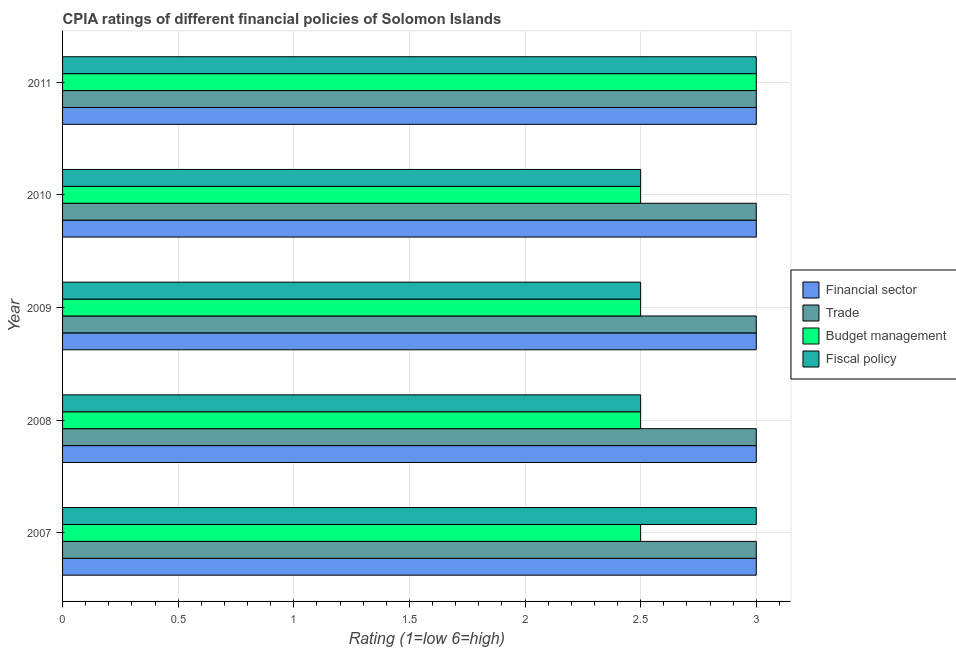How many different coloured bars are there?
Offer a very short reply. 4. Are the number of bars on each tick of the Y-axis equal?
Make the answer very short. Yes. How many bars are there on the 1st tick from the top?
Your answer should be compact. 4. What is the cpia rating of trade in 2007?
Give a very brief answer. 3. Across all years, what is the maximum cpia rating of trade?
Offer a very short reply. 3. Across all years, what is the minimum cpia rating of financial sector?
Make the answer very short. 3. In which year was the cpia rating of trade minimum?
Your response must be concise. 2007. What is the total cpia rating of fiscal policy in the graph?
Give a very brief answer. 13.5. In the year 2009, what is the difference between the cpia rating of fiscal policy and cpia rating of financial sector?
Provide a short and direct response. -0.5. Is the cpia rating of budget management in 2008 less than that in 2011?
Provide a succinct answer. Yes. Is the difference between the cpia rating of fiscal policy in 2009 and 2011 greater than the difference between the cpia rating of financial sector in 2009 and 2011?
Provide a short and direct response. No. In how many years, is the cpia rating of financial sector greater than the average cpia rating of financial sector taken over all years?
Ensure brevity in your answer.  0. Is the sum of the cpia rating of financial sector in 2007 and 2009 greater than the maximum cpia rating of fiscal policy across all years?
Your answer should be very brief. Yes. What does the 2nd bar from the top in 2008 represents?
Ensure brevity in your answer.  Budget management. What does the 3rd bar from the bottom in 2007 represents?
Ensure brevity in your answer.  Budget management. Are all the bars in the graph horizontal?
Provide a succinct answer. Yes. Does the graph contain any zero values?
Provide a succinct answer. No. Does the graph contain grids?
Keep it short and to the point. Yes. Where does the legend appear in the graph?
Your response must be concise. Center right. What is the title of the graph?
Offer a very short reply. CPIA ratings of different financial policies of Solomon Islands. Does "Trade" appear as one of the legend labels in the graph?
Make the answer very short. Yes. What is the label or title of the X-axis?
Your response must be concise. Rating (1=low 6=high). What is the label or title of the Y-axis?
Offer a terse response. Year. What is the Rating (1=low 6=high) of Trade in 2007?
Your answer should be compact. 3. What is the Rating (1=low 6=high) in Trade in 2008?
Your answer should be compact. 3. What is the Rating (1=low 6=high) in Fiscal policy in 2008?
Make the answer very short. 2.5. What is the Rating (1=low 6=high) of Budget management in 2009?
Provide a short and direct response. 2.5. What is the Rating (1=low 6=high) in Fiscal policy in 2009?
Offer a very short reply. 2.5. What is the Rating (1=low 6=high) of Fiscal policy in 2010?
Ensure brevity in your answer.  2.5. What is the Rating (1=low 6=high) in Financial sector in 2011?
Ensure brevity in your answer.  3. What is the Rating (1=low 6=high) in Budget management in 2011?
Offer a very short reply. 3. What is the Rating (1=low 6=high) of Fiscal policy in 2011?
Offer a terse response. 3. Across all years, what is the maximum Rating (1=low 6=high) of Financial sector?
Offer a terse response. 3. Across all years, what is the maximum Rating (1=low 6=high) of Fiscal policy?
Your response must be concise. 3. Across all years, what is the minimum Rating (1=low 6=high) of Budget management?
Provide a short and direct response. 2.5. Across all years, what is the minimum Rating (1=low 6=high) of Fiscal policy?
Provide a succinct answer. 2.5. What is the total Rating (1=low 6=high) of Fiscal policy in the graph?
Your response must be concise. 13.5. What is the difference between the Rating (1=low 6=high) of Financial sector in 2007 and that in 2008?
Provide a succinct answer. 0. What is the difference between the Rating (1=low 6=high) of Trade in 2007 and that in 2008?
Your answer should be compact. 0. What is the difference between the Rating (1=low 6=high) in Budget management in 2007 and that in 2008?
Offer a terse response. 0. What is the difference between the Rating (1=low 6=high) of Budget management in 2007 and that in 2009?
Ensure brevity in your answer.  0. What is the difference between the Rating (1=low 6=high) of Fiscal policy in 2007 and that in 2009?
Make the answer very short. 0.5. What is the difference between the Rating (1=low 6=high) in Financial sector in 2007 and that in 2010?
Ensure brevity in your answer.  0. What is the difference between the Rating (1=low 6=high) in Trade in 2007 and that in 2010?
Give a very brief answer. 0. What is the difference between the Rating (1=low 6=high) in Budget management in 2007 and that in 2010?
Your response must be concise. 0. What is the difference between the Rating (1=low 6=high) in Fiscal policy in 2007 and that in 2010?
Ensure brevity in your answer.  0.5. What is the difference between the Rating (1=low 6=high) in Budget management in 2007 and that in 2011?
Give a very brief answer. -0.5. What is the difference between the Rating (1=low 6=high) of Budget management in 2008 and that in 2009?
Make the answer very short. 0. What is the difference between the Rating (1=low 6=high) in Trade in 2008 and that in 2010?
Make the answer very short. 0. What is the difference between the Rating (1=low 6=high) of Budget management in 2008 and that in 2010?
Ensure brevity in your answer.  0. What is the difference between the Rating (1=low 6=high) in Financial sector in 2008 and that in 2011?
Provide a short and direct response. 0. What is the difference between the Rating (1=low 6=high) of Trade in 2008 and that in 2011?
Offer a very short reply. 0. What is the difference between the Rating (1=low 6=high) of Budget management in 2008 and that in 2011?
Your answer should be compact. -0.5. What is the difference between the Rating (1=low 6=high) of Fiscal policy in 2008 and that in 2011?
Your answer should be compact. -0.5. What is the difference between the Rating (1=low 6=high) of Financial sector in 2009 and that in 2010?
Offer a terse response. 0. What is the difference between the Rating (1=low 6=high) of Trade in 2009 and that in 2010?
Make the answer very short. 0. What is the difference between the Rating (1=low 6=high) of Budget management in 2009 and that in 2010?
Provide a short and direct response. 0. What is the difference between the Rating (1=low 6=high) of Financial sector in 2009 and that in 2011?
Provide a short and direct response. 0. What is the difference between the Rating (1=low 6=high) of Budget management in 2009 and that in 2011?
Provide a succinct answer. -0.5. What is the difference between the Rating (1=low 6=high) in Fiscal policy in 2009 and that in 2011?
Offer a terse response. -0.5. What is the difference between the Rating (1=low 6=high) in Trade in 2010 and that in 2011?
Your answer should be compact. 0. What is the difference between the Rating (1=low 6=high) of Budget management in 2010 and that in 2011?
Offer a very short reply. -0.5. What is the difference between the Rating (1=low 6=high) in Financial sector in 2007 and the Rating (1=low 6=high) in Budget management in 2008?
Offer a terse response. 0.5. What is the difference between the Rating (1=low 6=high) of Trade in 2007 and the Rating (1=low 6=high) of Budget management in 2008?
Give a very brief answer. 0.5. What is the difference between the Rating (1=low 6=high) of Budget management in 2007 and the Rating (1=low 6=high) of Fiscal policy in 2008?
Offer a very short reply. 0. What is the difference between the Rating (1=low 6=high) of Financial sector in 2007 and the Rating (1=low 6=high) of Budget management in 2009?
Ensure brevity in your answer.  0.5. What is the difference between the Rating (1=low 6=high) in Financial sector in 2007 and the Rating (1=low 6=high) in Fiscal policy in 2009?
Offer a terse response. 0.5. What is the difference between the Rating (1=low 6=high) in Trade in 2007 and the Rating (1=low 6=high) in Budget management in 2009?
Your response must be concise. 0.5. What is the difference between the Rating (1=low 6=high) in Trade in 2007 and the Rating (1=low 6=high) in Fiscal policy in 2009?
Give a very brief answer. 0.5. What is the difference between the Rating (1=low 6=high) in Budget management in 2007 and the Rating (1=low 6=high) in Fiscal policy in 2009?
Offer a very short reply. 0. What is the difference between the Rating (1=low 6=high) in Financial sector in 2007 and the Rating (1=low 6=high) in Budget management in 2010?
Offer a very short reply. 0.5. What is the difference between the Rating (1=low 6=high) of Financial sector in 2007 and the Rating (1=low 6=high) of Fiscal policy in 2010?
Offer a terse response. 0.5. What is the difference between the Rating (1=low 6=high) in Trade in 2007 and the Rating (1=low 6=high) in Budget management in 2010?
Make the answer very short. 0.5. What is the difference between the Rating (1=low 6=high) in Financial sector in 2007 and the Rating (1=low 6=high) in Budget management in 2011?
Provide a succinct answer. 0. What is the difference between the Rating (1=low 6=high) of Financial sector in 2007 and the Rating (1=low 6=high) of Fiscal policy in 2011?
Your answer should be compact. 0. What is the difference between the Rating (1=low 6=high) in Trade in 2007 and the Rating (1=low 6=high) in Budget management in 2011?
Provide a succinct answer. 0. What is the difference between the Rating (1=low 6=high) of Trade in 2007 and the Rating (1=low 6=high) of Fiscal policy in 2011?
Your response must be concise. 0. What is the difference between the Rating (1=low 6=high) in Financial sector in 2008 and the Rating (1=low 6=high) in Fiscal policy in 2009?
Offer a very short reply. 0.5. What is the difference between the Rating (1=low 6=high) in Trade in 2008 and the Rating (1=low 6=high) in Budget management in 2009?
Provide a succinct answer. 0.5. What is the difference between the Rating (1=low 6=high) of Financial sector in 2008 and the Rating (1=low 6=high) of Fiscal policy in 2010?
Provide a succinct answer. 0.5. What is the difference between the Rating (1=low 6=high) in Trade in 2008 and the Rating (1=low 6=high) in Budget management in 2010?
Your answer should be compact. 0.5. What is the difference between the Rating (1=low 6=high) in Financial sector in 2008 and the Rating (1=low 6=high) in Trade in 2011?
Make the answer very short. 0. What is the difference between the Rating (1=low 6=high) of Financial sector in 2008 and the Rating (1=low 6=high) of Budget management in 2011?
Provide a short and direct response. 0. What is the difference between the Rating (1=low 6=high) of Financial sector in 2008 and the Rating (1=low 6=high) of Fiscal policy in 2011?
Offer a very short reply. 0. What is the difference between the Rating (1=low 6=high) of Budget management in 2008 and the Rating (1=low 6=high) of Fiscal policy in 2011?
Your answer should be compact. -0.5. What is the difference between the Rating (1=low 6=high) of Financial sector in 2009 and the Rating (1=low 6=high) of Budget management in 2010?
Provide a succinct answer. 0.5. What is the difference between the Rating (1=low 6=high) in Trade in 2009 and the Rating (1=low 6=high) in Fiscal policy in 2010?
Your answer should be compact. 0.5. What is the difference between the Rating (1=low 6=high) of Financial sector in 2009 and the Rating (1=low 6=high) of Fiscal policy in 2011?
Offer a very short reply. 0. What is the difference between the Rating (1=low 6=high) of Financial sector in 2010 and the Rating (1=low 6=high) of Budget management in 2011?
Your answer should be very brief. 0. What is the difference between the Rating (1=low 6=high) in Trade in 2010 and the Rating (1=low 6=high) in Budget management in 2011?
Ensure brevity in your answer.  0. What is the difference between the Rating (1=low 6=high) of Budget management in 2010 and the Rating (1=low 6=high) of Fiscal policy in 2011?
Your response must be concise. -0.5. In the year 2007, what is the difference between the Rating (1=low 6=high) of Financial sector and Rating (1=low 6=high) of Trade?
Offer a very short reply. 0. In the year 2007, what is the difference between the Rating (1=low 6=high) in Financial sector and Rating (1=low 6=high) in Budget management?
Ensure brevity in your answer.  0.5. In the year 2007, what is the difference between the Rating (1=low 6=high) in Financial sector and Rating (1=low 6=high) in Fiscal policy?
Your response must be concise. 0. In the year 2007, what is the difference between the Rating (1=low 6=high) in Trade and Rating (1=low 6=high) in Budget management?
Your response must be concise. 0.5. In the year 2007, what is the difference between the Rating (1=low 6=high) of Trade and Rating (1=low 6=high) of Fiscal policy?
Offer a terse response. 0. In the year 2008, what is the difference between the Rating (1=low 6=high) in Financial sector and Rating (1=low 6=high) in Trade?
Keep it short and to the point. 0. In the year 2008, what is the difference between the Rating (1=low 6=high) in Trade and Rating (1=low 6=high) in Budget management?
Offer a very short reply. 0.5. In the year 2009, what is the difference between the Rating (1=low 6=high) of Financial sector and Rating (1=low 6=high) of Fiscal policy?
Make the answer very short. 0.5. In the year 2009, what is the difference between the Rating (1=low 6=high) in Budget management and Rating (1=low 6=high) in Fiscal policy?
Provide a short and direct response. 0. In the year 2010, what is the difference between the Rating (1=low 6=high) of Financial sector and Rating (1=low 6=high) of Fiscal policy?
Ensure brevity in your answer.  0.5. In the year 2010, what is the difference between the Rating (1=low 6=high) in Budget management and Rating (1=low 6=high) in Fiscal policy?
Your answer should be very brief. 0. In the year 2011, what is the difference between the Rating (1=low 6=high) of Financial sector and Rating (1=low 6=high) of Trade?
Give a very brief answer. 0. In the year 2011, what is the difference between the Rating (1=low 6=high) in Trade and Rating (1=low 6=high) in Fiscal policy?
Offer a terse response. 0. In the year 2011, what is the difference between the Rating (1=low 6=high) of Budget management and Rating (1=low 6=high) of Fiscal policy?
Ensure brevity in your answer.  0. What is the ratio of the Rating (1=low 6=high) of Financial sector in 2007 to that in 2008?
Offer a terse response. 1. What is the ratio of the Rating (1=low 6=high) in Financial sector in 2007 to that in 2009?
Your answer should be very brief. 1. What is the ratio of the Rating (1=low 6=high) of Budget management in 2007 to that in 2009?
Provide a succinct answer. 1. What is the ratio of the Rating (1=low 6=high) in Fiscal policy in 2007 to that in 2009?
Give a very brief answer. 1.2. What is the ratio of the Rating (1=low 6=high) in Financial sector in 2007 to that in 2010?
Your answer should be compact. 1. What is the ratio of the Rating (1=low 6=high) of Budget management in 2007 to that in 2010?
Provide a succinct answer. 1. What is the ratio of the Rating (1=low 6=high) of Financial sector in 2007 to that in 2011?
Offer a very short reply. 1. What is the ratio of the Rating (1=low 6=high) of Fiscal policy in 2007 to that in 2011?
Your answer should be very brief. 1. What is the ratio of the Rating (1=low 6=high) of Budget management in 2008 to that in 2009?
Provide a short and direct response. 1. What is the ratio of the Rating (1=low 6=high) in Financial sector in 2008 to that in 2010?
Provide a succinct answer. 1. What is the ratio of the Rating (1=low 6=high) in Trade in 2008 to that in 2010?
Offer a terse response. 1. What is the ratio of the Rating (1=low 6=high) in Budget management in 2008 to that in 2010?
Ensure brevity in your answer.  1. What is the ratio of the Rating (1=low 6=high) in Budget management in 2008 to that in 2011?
Provide a succinct answer. 0.83. What is the ratio of the Rating (1=low 6=high) of Trade in 2009 to that in 2010?
Provide a succinct answer. 1. What is the ratio of the Rating (1=low 6=high) in Fiscal policy in 2009 to that in 2010?
Provide a succinct answer. 1. What is the ratio of the Rating (1=low 6=high) in Financial sector in 2009 to that in 2011?
Your answer should be compact. 1. What is the ratio of the Rating (1=low 6=high) in Trade in 2009 to that in 2011?
Your answer should be compact. 1. What is the ratio of the Rating (1=low 6=high) in Budget management in 2009 to that in 2011?
Offer a very short reply. 0.83. What is the ratio of the Rating (1=low 6=high) in Trade in 2010 to that in 2011?
Provide a short and direct response. 1. What is the ratio of the Rating (1=low 6=high) in Budget management in 2010 to that in 2011?
Your answer should be very brief. 0.83. What is the difference between the highest and the second highest Rating (1=low 6=high) of Financial sector?
Your answer should be very brief. 0. What is the difference between the highest and the second highest Rating (1=low 6=high) in Trade?
Offer a terse response. 0. What is the difference between the highest and the second highest Rating (1=low 6=high) of Budget management?
Provide a short and direct response. 0.5. What is the difference between the highest and the second highest Rating (1=low 6=high) of Fiscal policy?
Offer a terse response. 0. 